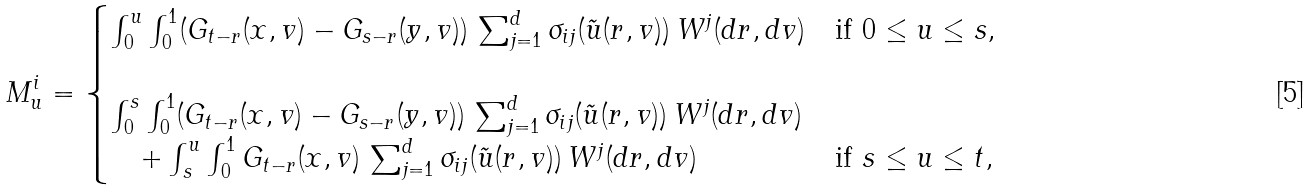<formula> <loc_0><loc_0><loc_500><loc_500>M ^ { i } _ { u } = \begin{cases} \int _ { 0 } ^ { u } \int _ { 0 } ^ { 1 } ( G _ { t - r } ( x , v ) - G _ { s - r } ( y , v ) ) \, \sum _ { j = 1 } ^ { d } \sigma _ { i j } ( \tilde { u } ( r , v ) ) \, W ^ { j } ( d r , d v ) & \text {if $0 \leq u \leq s $} , \\ & \\ \int _ { 0 } ^ { s } \int _ { 0 } ^ { 1 } ( G _ { t - r } ( x , v ) - G _ { s - r } ( y , v ) ) \, \sum _ { j = 1 } ^ { d } \sigma _ { i j } ( \tilde { u } ( r , v ) ) \, W ^ { j } ( d r , d v ) & \\ \quad + \int _ { s } ^ { u } \int _ { 0 } ^ { 1 } G _ { t - r } ( x , v ) \, \sum _ { j = 1 } ^ { d } \sigma _ { i j } ( \tilde { u } ( r , v ) ) \, W ^ { j } ( d r , d v ) & \text {if $s \leq u \leq t$} , \end{cases}</formula> 